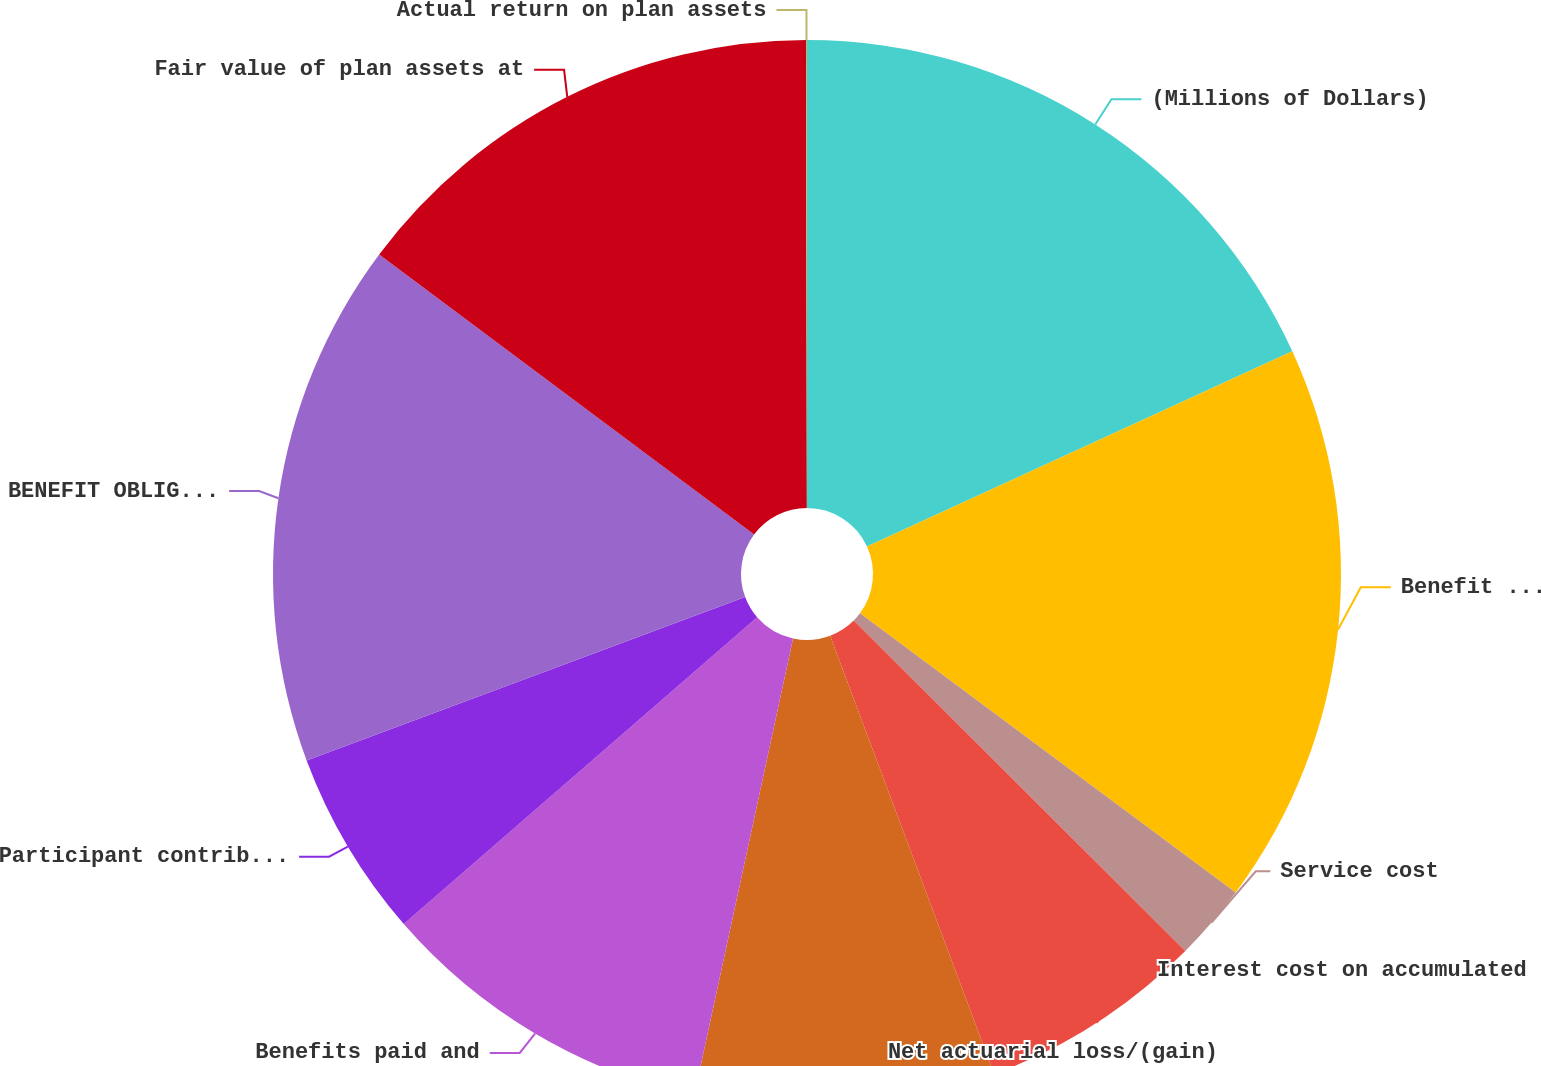<chart> <loc_0><loc_0><loc_500><loc_500><pie_chart><fcel>(Millions of Dollars)<fcel>Benefit obligation at<fcel>Service cost<fcel>Interest cost on accumulated<fcel>Net actuarial loss/(gain)<fcel>Benefits paid and<fcel>Participant contributions<fcel>BENEFIT OBLIGATION AT END OF<fcel>Fair value of plan assets at<fcel>Actual return on plan assets<nl><fcel>18.15%<fcel>17.02%<fcel>2.3%<fcel>6.83%<fcel>9.09%<fcel>10.23%<fcel>5.7%<fcel>15.89%<fcel>14.76%<fcel>0.03%<nl></chart> 